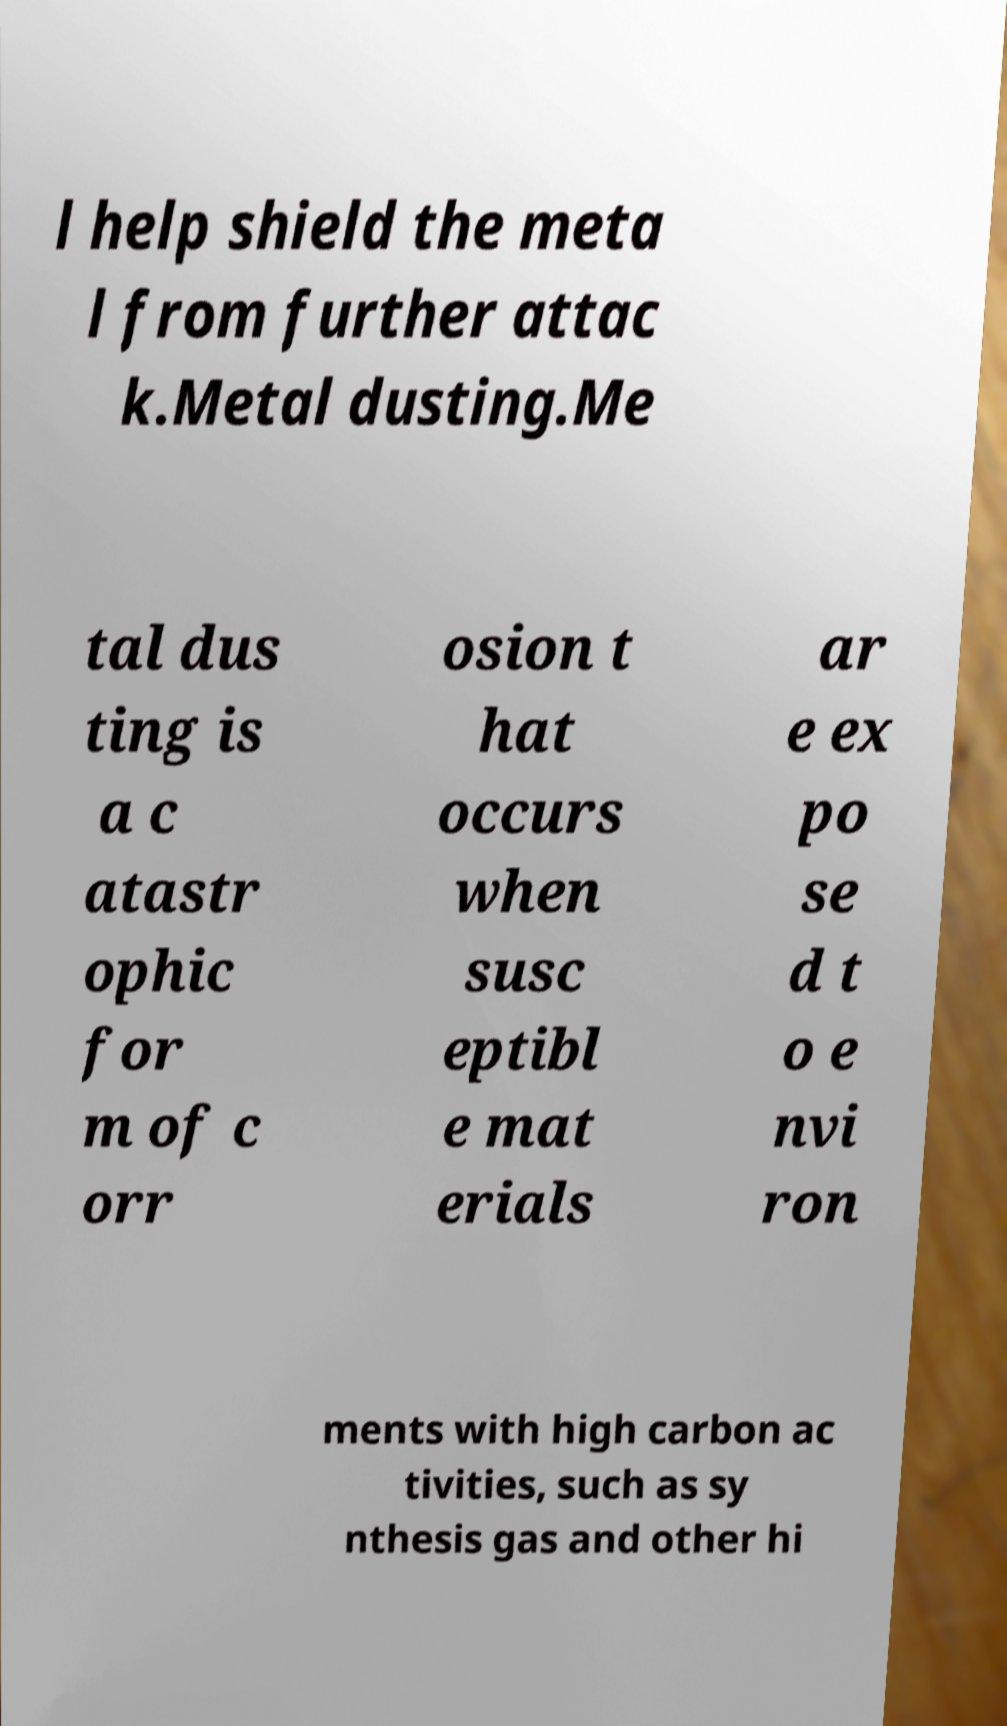Please read and relay the text visible in this image. What does it say? l help shield the meta l from further attac k.Metal dusting.Me tal dus ting is a c atastr ophic for m of c orr osion t hat occurs when susc eptibl e mat erials ar e ex po se d t o e nvi ron ments with high carbon ac tivities, such as sy nthesis gas and other hi 